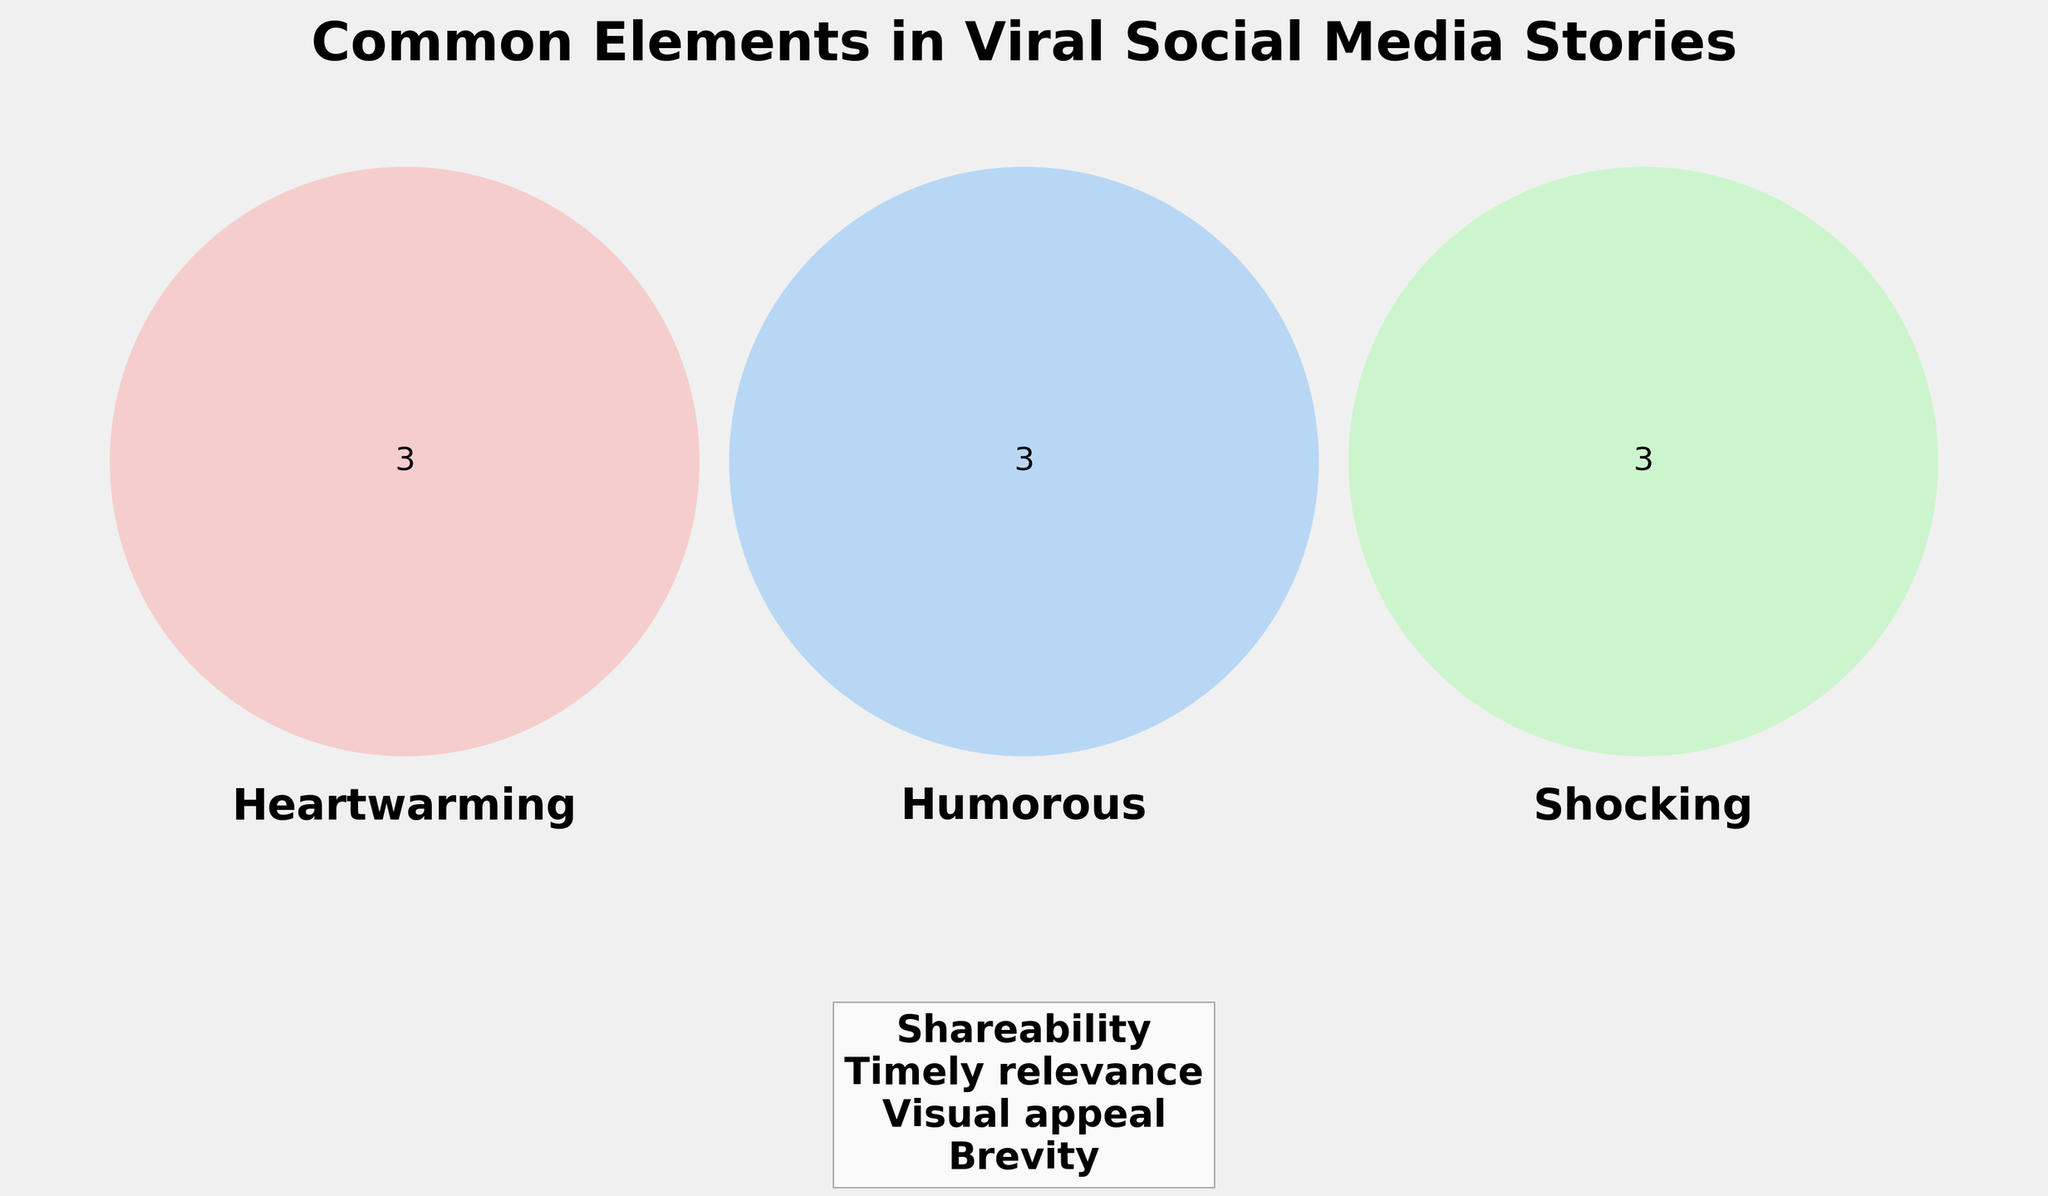What are the common elements among Heartwarming, Humorous, and Shocking stories? The Venn Diagram shows the intersection areas of the three categories. Look for the elements that overlap between Heartwarming, Humorous, and Shocking.
Answer: None Which sections contain 'Relatable characters'? Identify the category or categories that list 'Relatable characters' within their respective section of the diagram.
Answer: Heartwarming, Humorous How many unique elements are listed for the Heartwarming category? Counting the elements that are only in the Heartwarming section including those overlapping with other categories.
Answer: 3 Which category shares the most elements with Shocking? To determine this, look at the intersections of Shocking with Heartwarming and Humorous, and compare the number of elements shared.
Answer: Humorous List all common elements that are found in every category. Analyzing the center text that lists elements common to Heartwarming, Humorous, Shocking, and 'All' categories.
Answer: Brevity, Shareability, Visual appeal, Timely relevance What is a unique element to the Humorous category? Inspect the section specific to Humorous without overlaps with other categories.
Answer: Clever punchlines How many common elements exist between Heartwarming and Humorous but not with Shocking? Look at their intersecting section excluding the area shared by Shocking.
Answer: 1 Which elements are unique to the Shocking category? Identify elements listed only in the Shocking section that do not overlap with other categories.
Answer: Unexpected twists, Controversial topics, Dramatic reveals What elements do all categories share by visualization? The common elements for all categories can be found under the central label in the Venn diagram showing overlap with 'All'.
Answer: Brevity, Shareability, Visual appeal, Timely relevance Which category seems to have the most diverse range of unique elements? Counting the elements listed under each category without considering overlaps with other categories.
Answer: Shocking 